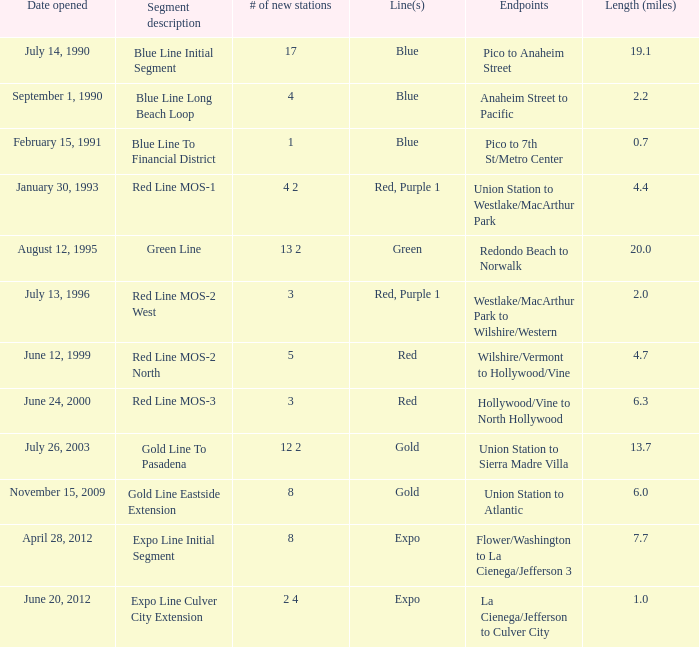What date of segment description red line mos-2 north open? June 12, 1999. 